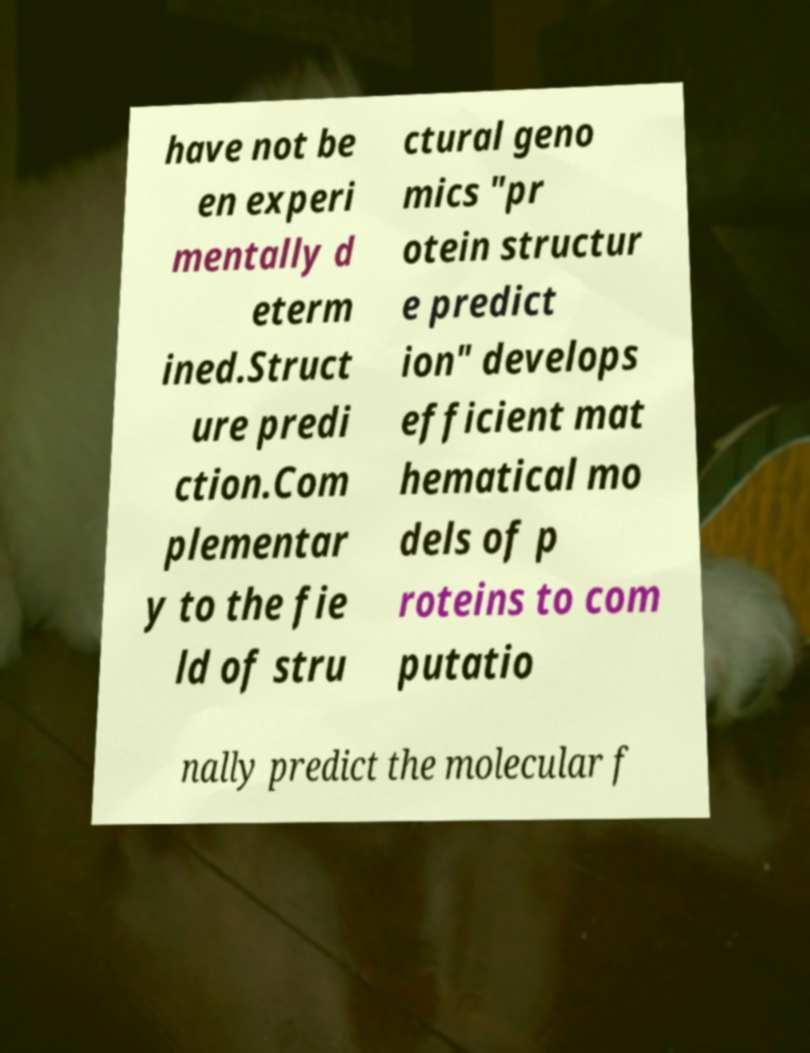For documentation purposes, I need the text within this image transcribed. Could you provide that? have not be en experi mentally d eterm ined.Struct ure predi ction.Com plementar y to the fie ld of stru ctural geno mics "pr otein structur e predict ion" develops efficient mat hematical mo dels of p roteins to com putatio nally predict the molecular f 